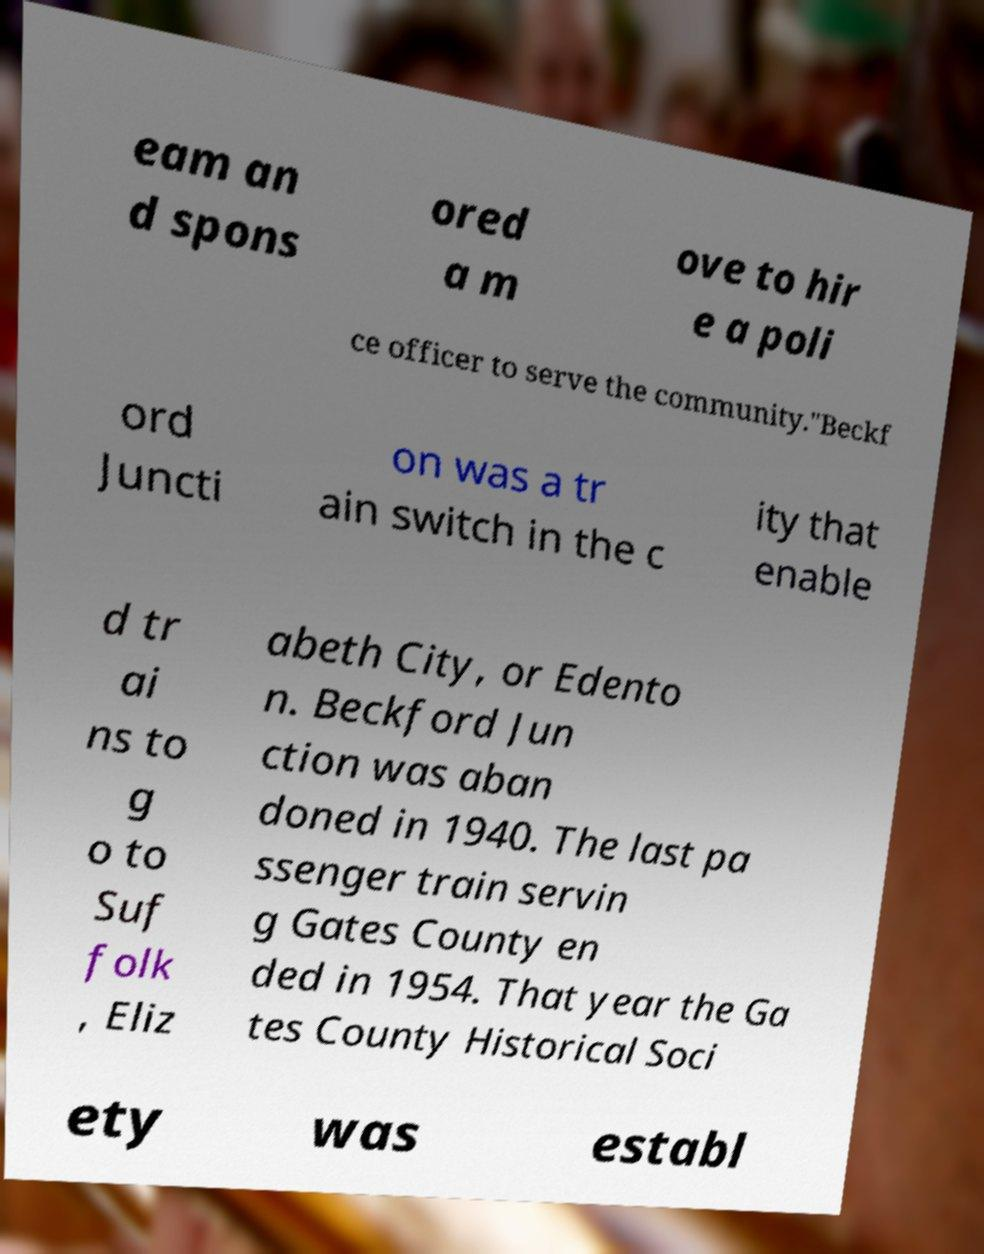For documentation purposes, I need the text within this image transcribed. Could you provide that? eam an d spons ored a m ove to hir e a poli ce officer to serve the community."Beckf ord Juncti on was a tr ain switch in the c ity that enable d tr ai ns to g o to Suf folk , Eliz abeth City, or Edento n. Beckford Jun ction was aban doned in 1940. The last pa ssenger train servin g Gates County en ded in 1954. That year the Ga tes County Historical Soci ety was establ 